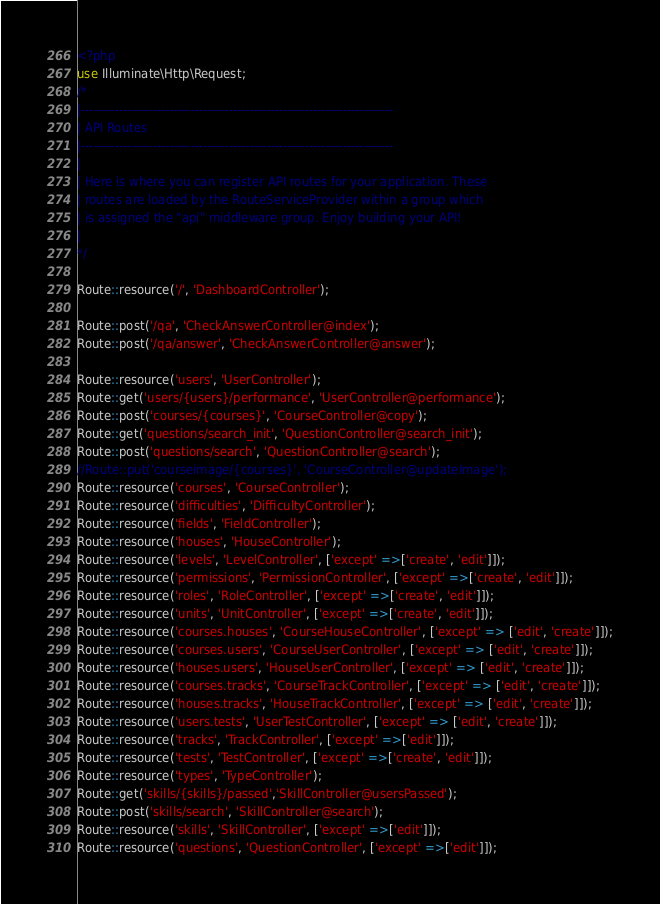Convert code to text. <code><loc_0><loc_0><loc_500><loc_500><_PHP_><?php
use Illuminate\Http\Request;
/*
|--------------------------------------------------------------------------
| API Routes
|--------------------------------------------------------------------------
|
| Here is where you can register API routes for your application. These
| routes are loaded by the RouteServiceProvider within a group which
| is assigned the "api" middleware group. Enjoy building your API!
|
*/

Route::resource('/', 'DashboardController');

Route::post('/qa', 'CheckAnswerController@index');
Route::post('/qa/answer', 'CheckAnswerController@answer');

Route::resource('users', 'UserController');
Route::get('users/{users}/performance', 'UserController@performance');
Route::post('courses/{courses}', 'CourseController@copy');
Route::get('questions/search_init', 'QuestionController@search_init');
Route::post('questions/search', 'QuestionController@search');
//Route::put('courseimage/{courses}', 'CourseController@updateImage');
Route::resource('courses', 'CourseController');
Route::resource('difficulties', 'DifficultyController');
Route::resource('fields', 'FieldController');
Route::resource('houses', 'HouseController');
Route::resource('levels', 'LevelController', ['except' =>['create', 'edit']]);
Route::resource('permissions', 'PermissionController', ['except' =>['create', 'edit']]);
Route::resource('roles', 'RoleController', ['except' =>['create', 'edit']]);
Route::resource('units', 'UnitController', ['except' =>['create', 'edit']]);
Route::resource('courses.houses', 'CourseHouseController', ['except' => ['edit', 'create']]);
Route::resource('courses.users', 'CourseUserController', ['except' => ['edit', 'create']]);
Route::resource('houses.users', 'HouseUserController', ['except' => ['edit', 'create']]);
Route::resource('courses.tracks', 'CourseTrackController', ['except' => ['edit', 'create']]);
Route::resource('houses.tracks', 'HouseTrackController', ['except' => ['edit', 'create']]);
Route::resource('users.tests', 'UserTestController', ['except' => ['edit', 'create']]);
Route::resource('tracks', 'TrackController', ['except' =>['edit']]);
Route::resource('tests', 'TestController', ['except' =>['create', 'edit']]);
Route::resource('types', 'TypeController');
Route::get('skills/{skills}/passed','SkillController@usersPassed');
Route::post('skills/search', 'SkillController@search');
Route::resource('skills', 'SkillController', ['except' =>['edit']]);
Route::resource('questions', 'QuestionController', ['except' =>['edit']]);</code> 